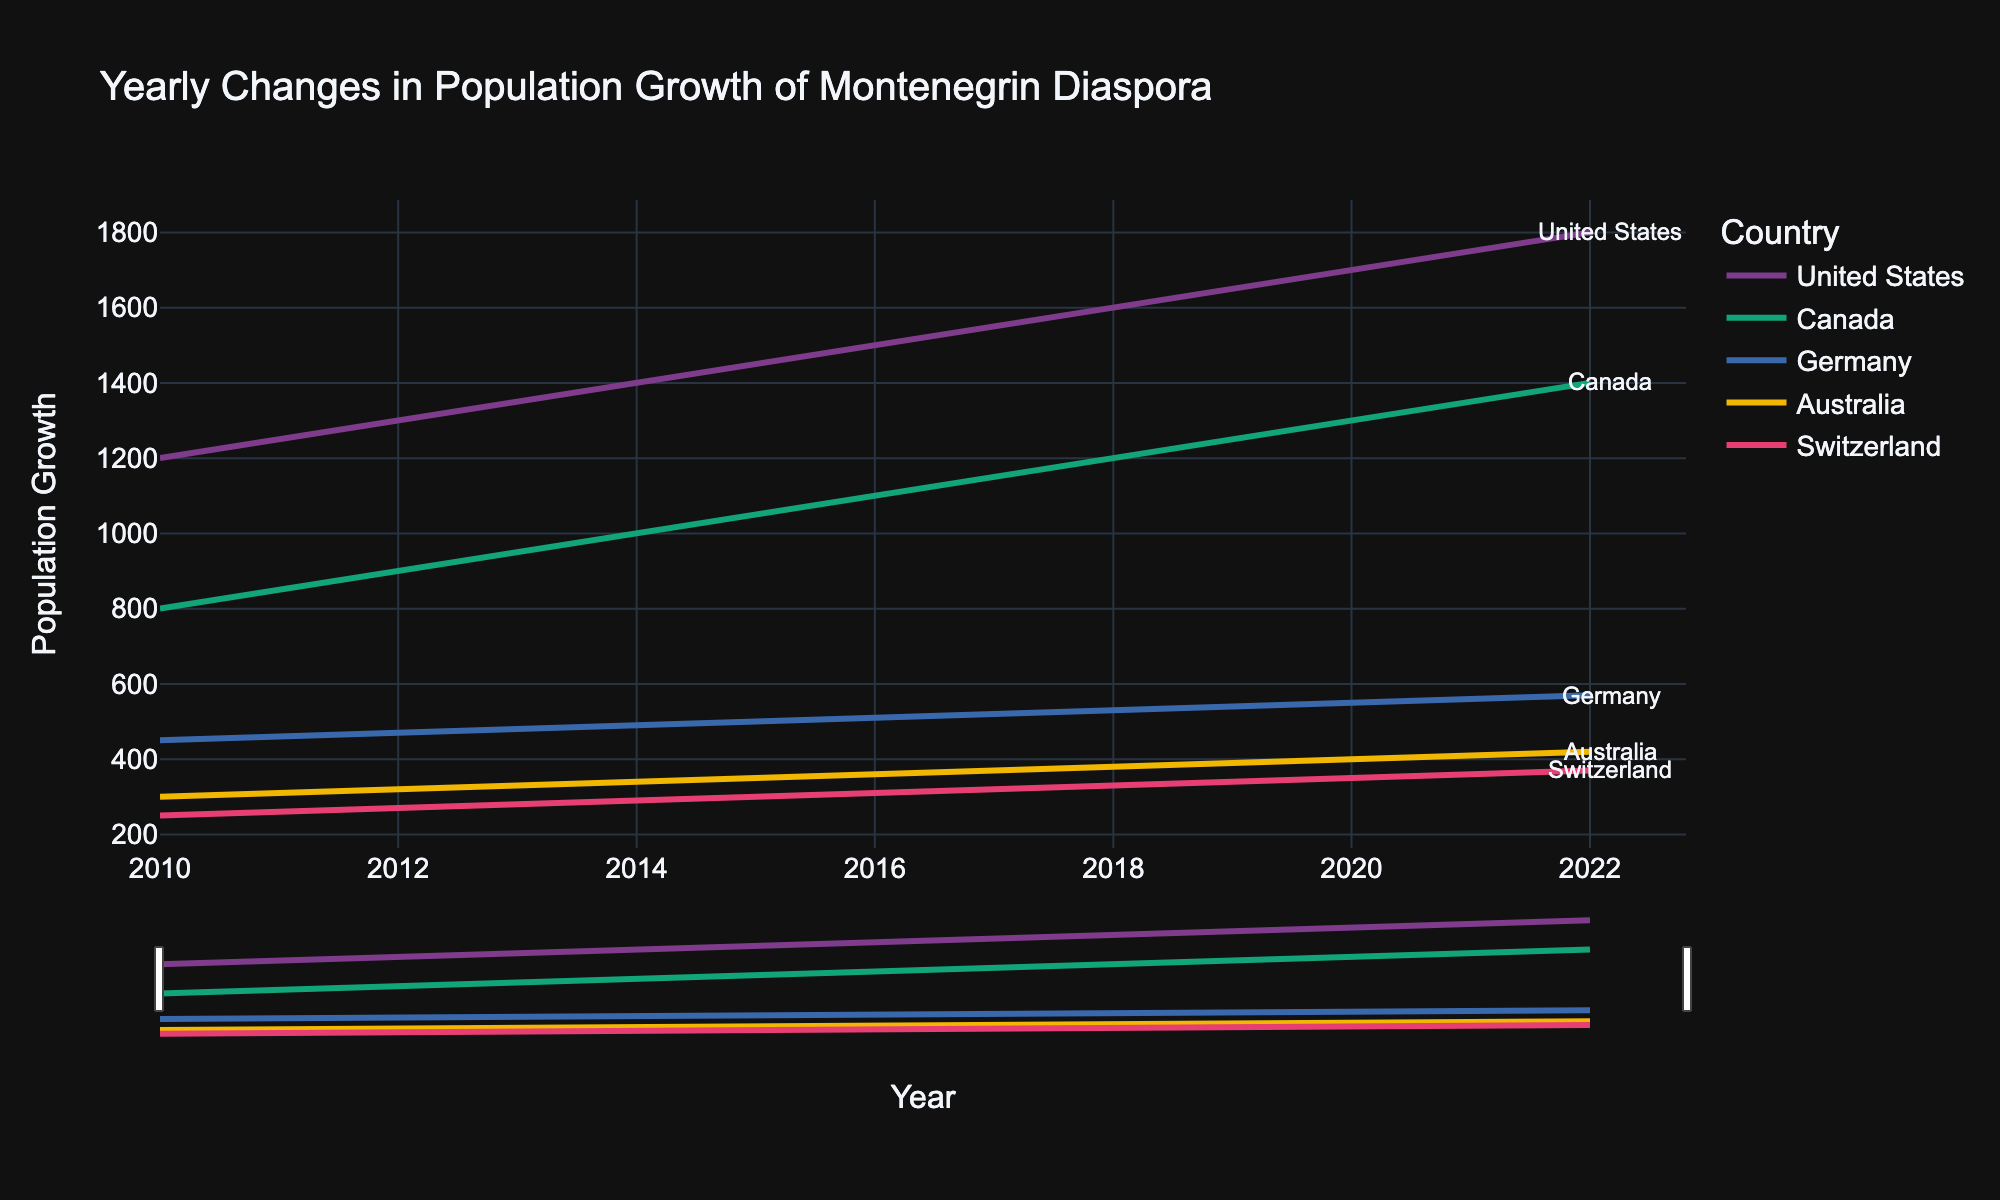What is the title of the plot? The title is located at the top of the figure. It typically describes what the plot represents. In this case, the title is “Yearly Changes in Population Growth of Montenegrin Diaspora”.
Answer: Yearly Changes in Population Growth of Montenegrin Diaspora Which country shows the highest population growth in 2019? To answer this question, locate the year 2019 on the x-axis and look for the highest point among all the plotted lines. According to the data, the United States shows the highest population growth in 2019.
Answer: United States What is the population growth for Canada in 2020? Find the line corresponding to Canada. Look for the point where this line intersects the year 2020 on the x-axis and read the value on the y-axis. In 2020, the population growth for Canada is 1300.
Answer: 1300 How many countries are represented in the plot? Counting the number of distinct lines in the plot gives the number of countries. According to the data, there are five countries: United States, Canada, Germany, Australia, and Switzerland.
Answer: 5 Compare the population growth trends of United States and Germany from 2010 to 2022. Which country has a steeper increase in growth? Look at the slopes of the lines for the United States and Germany over the years 2010 to 2022. The line for the United States shows a steeper increase compared to the line for Germany.
Answer: United States What is the population growth difference between the United States and Australia in 2022? Locate the 2022 values for both the United States and Australia on the y-axis. Subtract the population growth of Australia from that of the United States: 1800 - 420 = 1380.
Answer: 1380 Which country had the smallest growth in population in 2011? Look at the plot's data points for the year 2011 and find the lowest value among them. According to the data, Switzerland had the smallest growth in population in 2011.
Answer: Switzerland On average, how much did the population growth for Canada increase per year between 2010 and 2022? Calculate the difference in population growth for Canada between 2010 and 2022 (1400 - 800 = 600). Divide this difference by the number of years (2022 - 2010 = 12) to find the average yearly increase: 600 / 12 = 50.
Answer: 50 For which country did the population growth increase by exactly 100 from 2011 to 2012? Compare the population growth values for each country between 2011 and 2012. The country where the difference is exactly 100 is Canada, as its population growth increased from 850 to 900.
Answer: Canada 